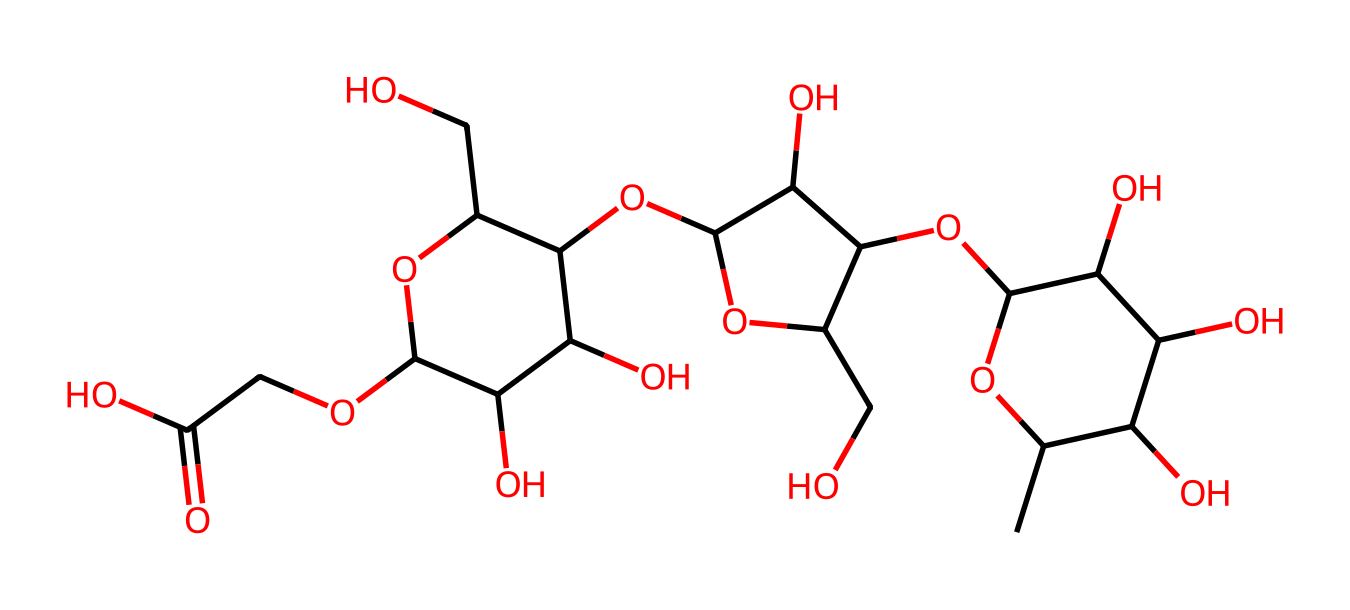What is the main functional group present in xanthan gum? The primary functional group in xanthan gum is the hydroxyl group, as evidenced by the multiple -OH groups present in the chemical structure.
Answer: hydroxyl group How many carbon atoms are in the xanthan gum structure? By examining the SMILES representation, we can count a total of 22 carbon atoms that make up the structure.
Answer: 22 What type of polysaccharide is xanthan gum classified as? Xanthan gum is classified as a heteropolysaccharide due to its composition of different types of monosaccharide units.
Answer: heteropolysaccharide Does xanthan gum exhibit shear-thinning behavior? Yes, xanthan gum is known for its shear-thinning property, which means its viscosity decreases under shear stress, making it easier to mix or pump.
Answer: yes What is the primary use of xanthan gum in food products? Xanthan gum is primarily used as a thickening agent, providing texture and stability to various food products, including plant-based meat alternatives.
Answer: thickening agent What does the presence of multiple -OH groups imply about xanthan gum? The presence of multiple -OH groups indicates that xanthan gum is hydrophilic, which allows it to interact with water and form gels or thicken liquids.
Answer: hydrophilic 